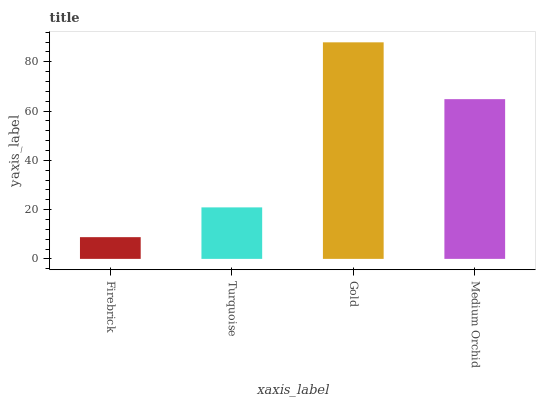Is Firebrick the minimum?
Answer yes or no. Yes. Is Gold the maximum?
Answer yes or no. Yes. Is Turquoise the minimum?
Answer yes or no. No. Is Turquoise the maximum?
Answer yes or no. No. Is Turquoise greater than Firebrick?
Answer yes or no. Yes. Is Firebrick less than Turquoise?
Answer yes or no. Yes. Is Firebrick greater than Turquoise?
Answer yes or no. No. Is Turquoise less than Firebrick?
Answer yes or no. No. Is Medium Orchid the high median?
Answer yes or no. Yes. Is Turquoise the low median?
Answer yes or no. Yes. Is Gold the high median?
Answer yes or no. No. Is Gold the low median?
Answer yes or no. No. 